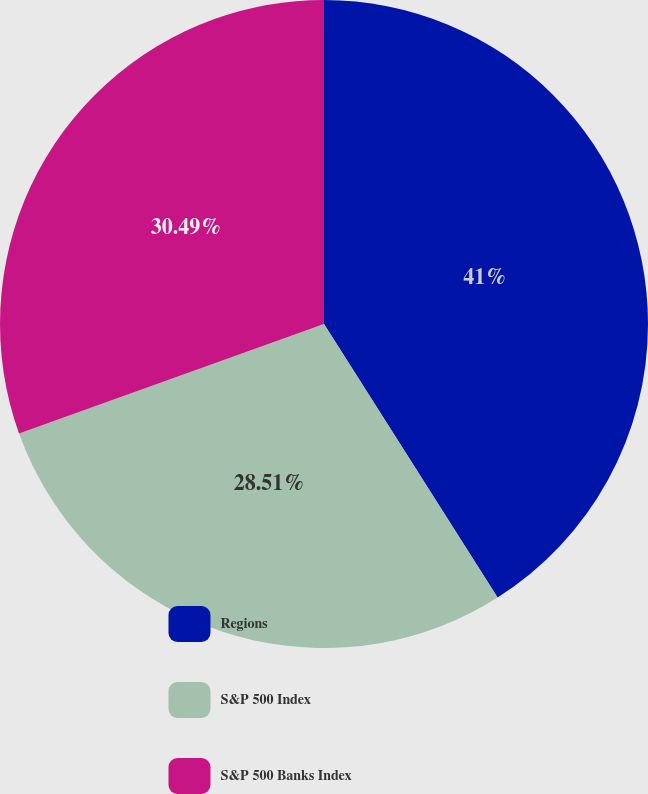Convert chart. <chart><loc_0><loc_0><loc_500><loc_500><pie_chart><fcel>Regions<fcel>S&P 500 Index<fcel>S&P 500 Banks Index<nl><fcel>41.0%<fcel>28.51%<fcel>30.49%<nl></chart> 